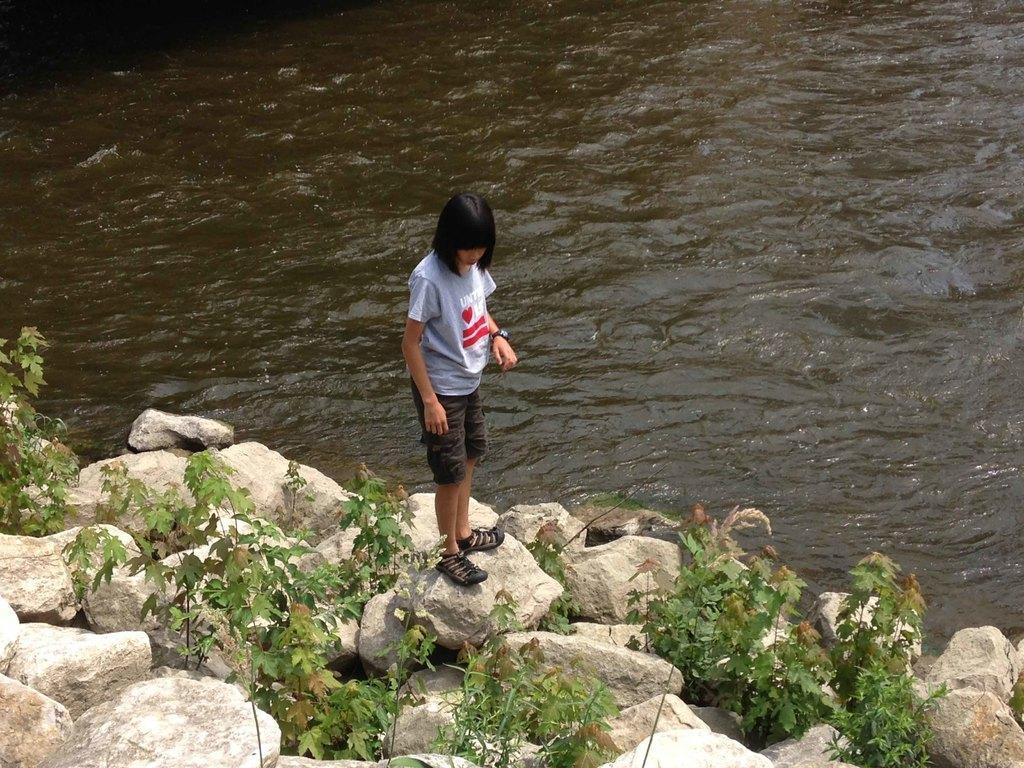In one or two sentences, can you explain what this image depicts? In this picture, there is a woman standing beside the river. She is standing on the stones. In between the stones, there are plants. She is wearing a purple top and brown shorts. 